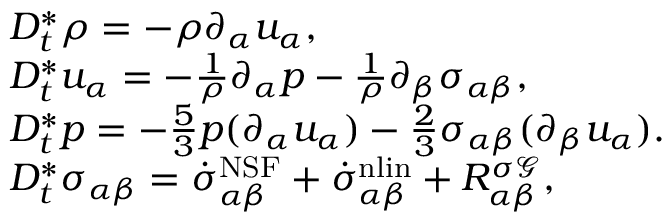<formula> <loc_0><loc_0><loc_500><loc_500>\begin{array} { r l } & { D _ { t } ^ { * } \rho = - \rho \partial _ { \alpha } u _ { \alpha } , } \\ & { D _ { t } ^ { * } u _ { \alpha } = - \frac { 1 } { \rho } \partial _ { \alpha } p - \frac { 1 } { \rho } \partial _ { \beta } { \sigma } _ { \alpha \beta } , } \\ & { D _ { t } ^ { * } p = - \frac { 5 } { 3 } p ( \partial _ { \alpha } u _ { \alpha } ) - \frac { 2 } { 3 } \sigma _ { \alpha \beta } ( \partial _ { \beta } u _ { \alpha } ) . } \\ & { D _ { t } ^ { * } \sigma _ { \alpha \beta } = \dot { \sigma } _ { \alpha \beta } ^ { N S F } + \dot { \sigma } _ { \alpha \beta } ^ { n l i n } + R _ { \alpha \beta } ^ { \sigma \mathcal { G } } , } \end{array}</formula> 